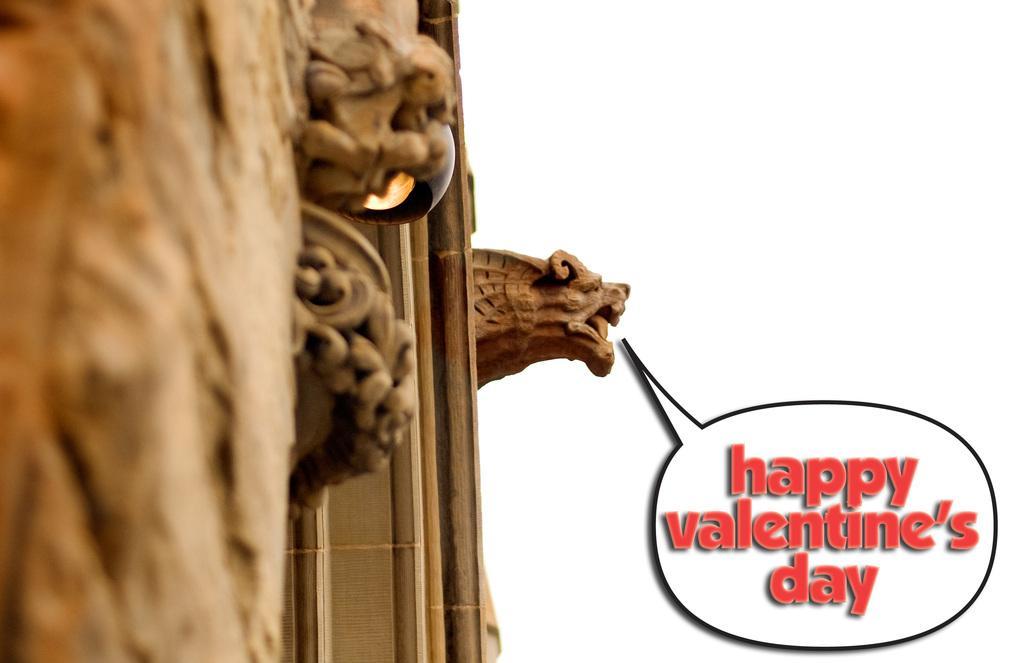Describe this image in one or two sentences. This image consists of a wall made up of wood on which there is a sculpture in the form lion. To the right, there is a text. 